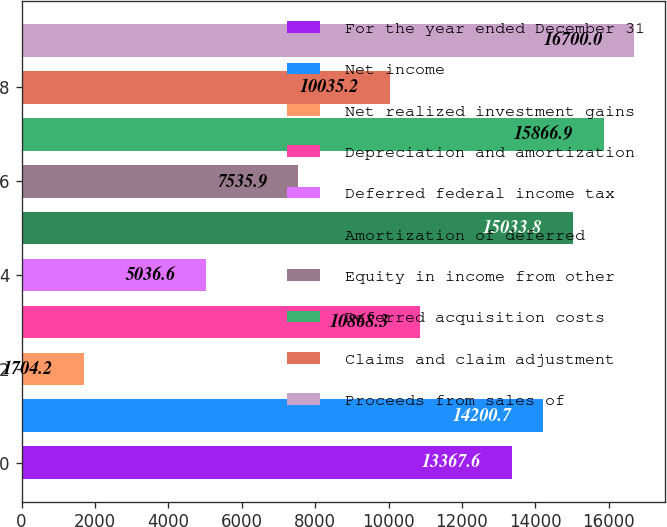<chart> <loc_0><loc_0><loc_500><loc_500><bar_chart><fcel>For the year ended December 31<fcel>Net income<fcel>Net realized investment gains<fcel>Depreciation and amortization<fcel>Deferred federal income tax<fcel>Amortization of deferred<fcel>Equity in income from other<fcel>Deferred acquisition costs<fcel>Claims and claim adjustment<fcel>Proceeds from sales of<nl><fcel>13367.6<fcel>14200.7<fcel>1704.2<fcel>10868.3<fcel>5036.6<fcel>15033.8<fcel>7535.9<fcel>15866.9<fcel>10035.2<fcel>16700<nl></chart> 